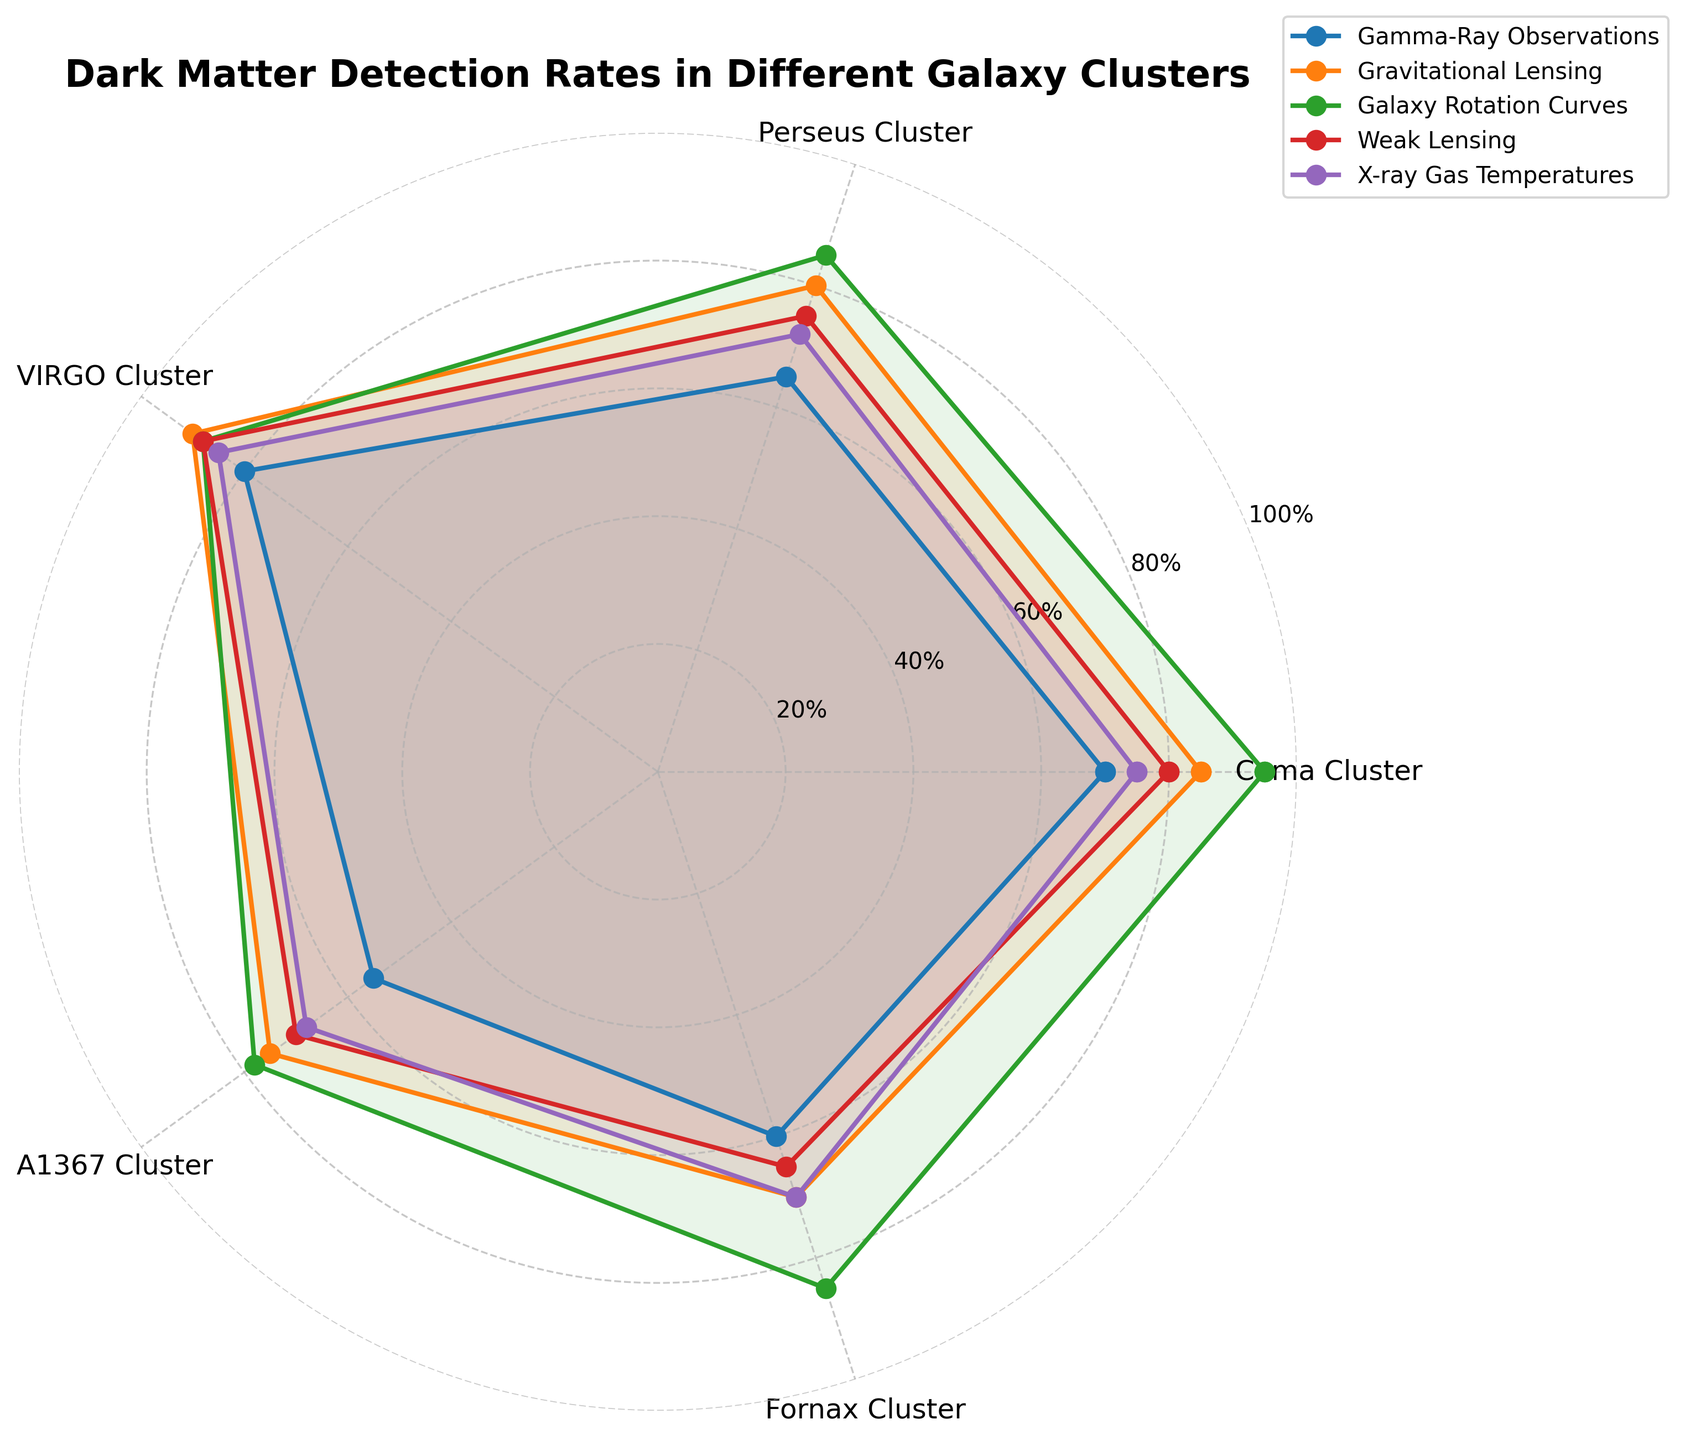What is the range of detection rates for Gamma-Ray Observations across all clusters? By examining the values for Gamma-Ray Observations in the legend of each galaxy cluster, we can see: Coma Cluster (70), Perseus Cluster (65), VIRGO Cluster (80), A1367 Cluster (55), Fornax Cluster (60). The range is the highest value minus the lowest value, which is 80 - 55.
Answer: 25 Which galaxy cluster shows the highest detection rate for Gravitational Lensing? We need to look at the value for Gravitational Lensing in the legend for each cluster. The values are: Coma Cluster (85), Perseus Cluster (80), VIRGO Cluster (90), A1367 Cluster (75), Fornax Cluster (70). The highest value is 90, which belongs to the VIRGO Cluster.
Answer: VIRGO Cluster Which detection method shows the least variance in rates among the five galaxy clusters? Observing the values for each detection method: Gamma-Ray Observations range from 55 to 80, Gravitational Lensing from 70 to 90, Galaxy Rotation Curves from 78 to 95, Weak Lensing from 65 to 88, and X-ray Gas Temperatures from 68 to 85. Weak Lensing, which ranges from 65 to 88, has the least variance.
Answer: Weak Lensing What is the average detection rate of X-ray Gas Temperatures across all clusters? By adding the X-ray Gas Temperatures values for each cluster (75, 72, 85, 68, 70), we get 75 + 72 + 85 + 68 + 70 = 370. Dividing this by the number of clusters (5) gives us the average: 370/5 = 74.
Answer: 74 Between the Coma and Perseus Clusters, which has higher average detection rates across all methods? Calculate the average for both clusters by summing their values and dividing by the number of methods: Coma Cluster (70 + 85 + 95 + 80 + 75)/5 = 81, and Perseus Cluster (65 + 80 + 85 + 75 + 72)/5 = 75.4. The Coma Cluster has a higher average.
Answer: Coma Cluster Which detection method shows the highest rate for the Fornax Cluster and what is its value? Examining the legend for the Fornax Cluster, the rates are: Gamma-Ray Observations (60), Gravitational Lensing (70), Galaxy Rotation Curves (85), Weak Lensing (65), X-ray Gas Temperatures (70). The highest value is 85 for Galaxy Rotation Curves.
Answer: Galaxy Rotation Curves, 85 How many methods show detection rates of 80 or above for the VIRGO Cluster? Looking at the legend values for the VIRGO Cluster: Gamma-Ray Observations (80), Gravitational Lensing (90), Galaxy Rotation Curves (88), Weak Lensing (88), X-ray Gas Temperatures (85). All five methods show detection rates of 80 or above.
Answer: 5 For which cluster is the detection rate of Weak Lensing closest to the detection rate of X-ray Gas Temperatures? Comparing the two values for each cluster, we see: Coma Cluster (80, 75), Perseus Cluster (75, 72), VIRGO Cluster (88, 85), A1367 Cluster (70, 68), Fornax Cluster (65, 70). The difference is smallest for the A1367 Cluster (70 - 68 = 2).
Answer: A1367 Cluster 